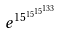Convert formula to latex. <formula><loc_0><loc_0><loc_500><loc_500>e ^ { 1 5 ^ { 1 5 ^ { 1 5 ^ { 1 3 3 } } } }</formula> 